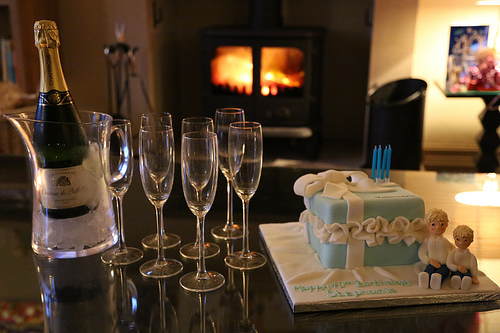<image>
Is there a champagne glass next to the fireplace? No. The champagne glass is not positioned next to the fireplace. They are located in different areas of the scene. Is the candles on the cake? Yes. Looking at the image, I can see the candles is positioned on top of the cake, with the cake providing support. Where is the wine in relation to the ice? Is it in front of the ice? No. The wine is not in front of the ice. The spatial positioning shows a different relationship between these objects. 